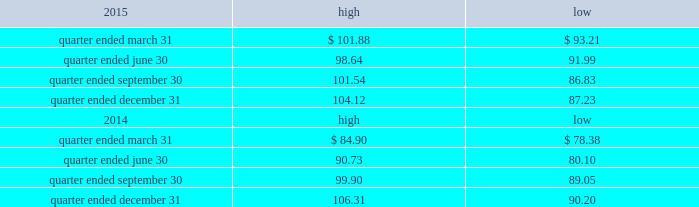Part ii item 5 .
Market for registrant 2019s common equity , related stockholder matters and issuer purchases of equity securities the table presents reported quarterly high and low per share sale prices of our common stock on the nyse for the years 2015 and 2014. .
On february 19 , 2016 , the closing price of our common stock was $ 87.32 per share as reported on the nyse .
As of february 19 , 2016 , we had 423897556 outstanding shares of common stock and 159 registered holders .
Dividends as a reit , we must annually distribute to our stockholders an amount equal to at least 90% ( 90 % ) of our reit taxable income ( determined before the deduction for distributed earnings and excluding any net capital gain ) .
Generally , we have distributed and expect to continue to distribute all or substantially all of our reit taxable income after taking into consideration our utilization of net operating losses ( 201cnols 201d ) .
We have two series of preferred stock outstanding , 5.25% ( 5.25 % ) mandatory convertible preferred stock , series a , issued in may 2014 ( the 201cseries a preferred stock 201d ) , with a dividend rate of 5.25% ( 5.25 % ) , and the 5.50% ( 5.50 % ) mandatory convertible preferred stock , series b ( the 201cseries b preferred stock 201d ) , issued in march 2015 , with a dividend rate of 5.50% ( 5.50 % ) .
Dividends are payable quarterly in arrears , subject to declaration by our board of directors .
The amount , timing and frequency of future distributions will be at the sole discretion of our board of directors and will be dependent upon various factors , a number of which may be beyond our control , including our financial condition and operating cash flows , the amount required to maintain our qualification for taxation as a reit and reduce any income and excise taxes that we otherwise would be required to pay , limitations on distributions in our existing and future debt and preferred equity instruments , our ability to utilize nols to offset our distribution requirements , limitations on our ability to fund distributions using cash generated through our trss and other factors that our board of directors may deem relevant .
We have distributed an aggregate of approximately $ 2.3 billion to our common stockholders , including the dividend paid in january 2016 , primarily subject to taxation as ordinary income .
During the year ended december 31 , 2015 , we declared the following cash distributions: .
What is the average number of shares per registered holder as of february 19 , 2016? 
Computations: (423897556 / 159)
Answer: 2666022.36478. 